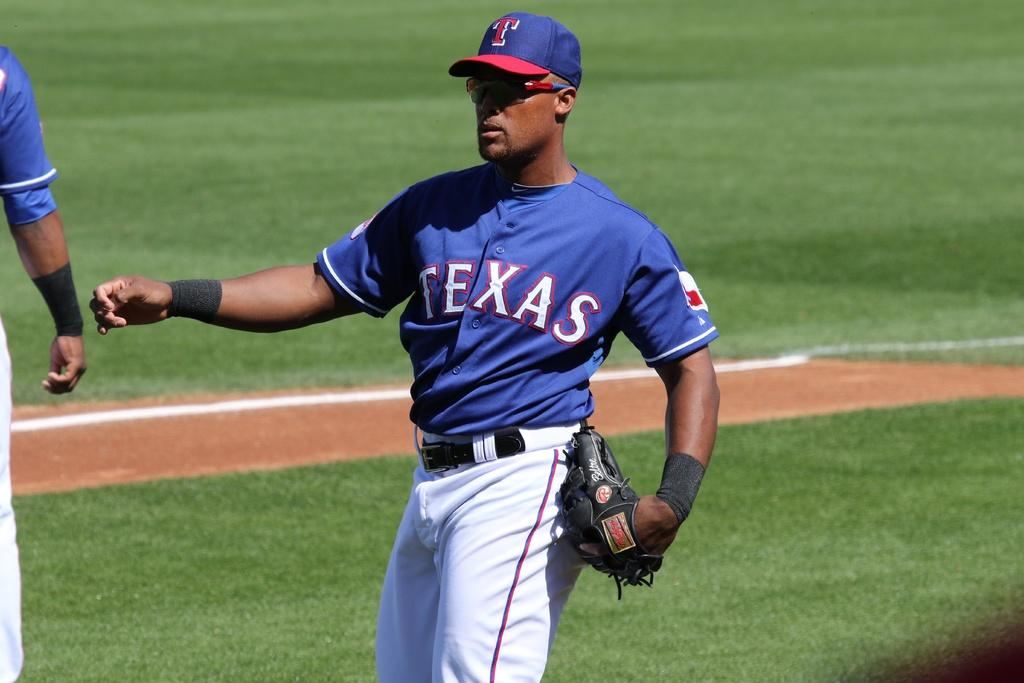What is the man in the image doing? The man is standing in the image. What is the man holding in the image? The man is holding a glove. What type of terrain is visible in the image? There is grass visible in the image. How many people are present in the image? There are two people in the image, one on the left side. What is the name of the scarecrow in the image? There is no scarecrow present in the image; it features a man standing and holding a glove. 